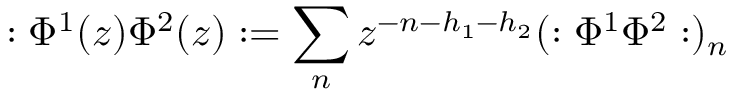Convert formula to latex. <formula><loc_0><loc_0><loc_500><loc_500>\colon \Phi ^ { 1 } ( z ) \Phi ^ { 2 } ( z ) \colon = \sum _ { n } z ^ { - n - h _ { 1 } - h _ { 2 } } ( \colon \Phi ^ { 1 } \Phi ^ { 2 } \colon ) _ { n }</formula> 